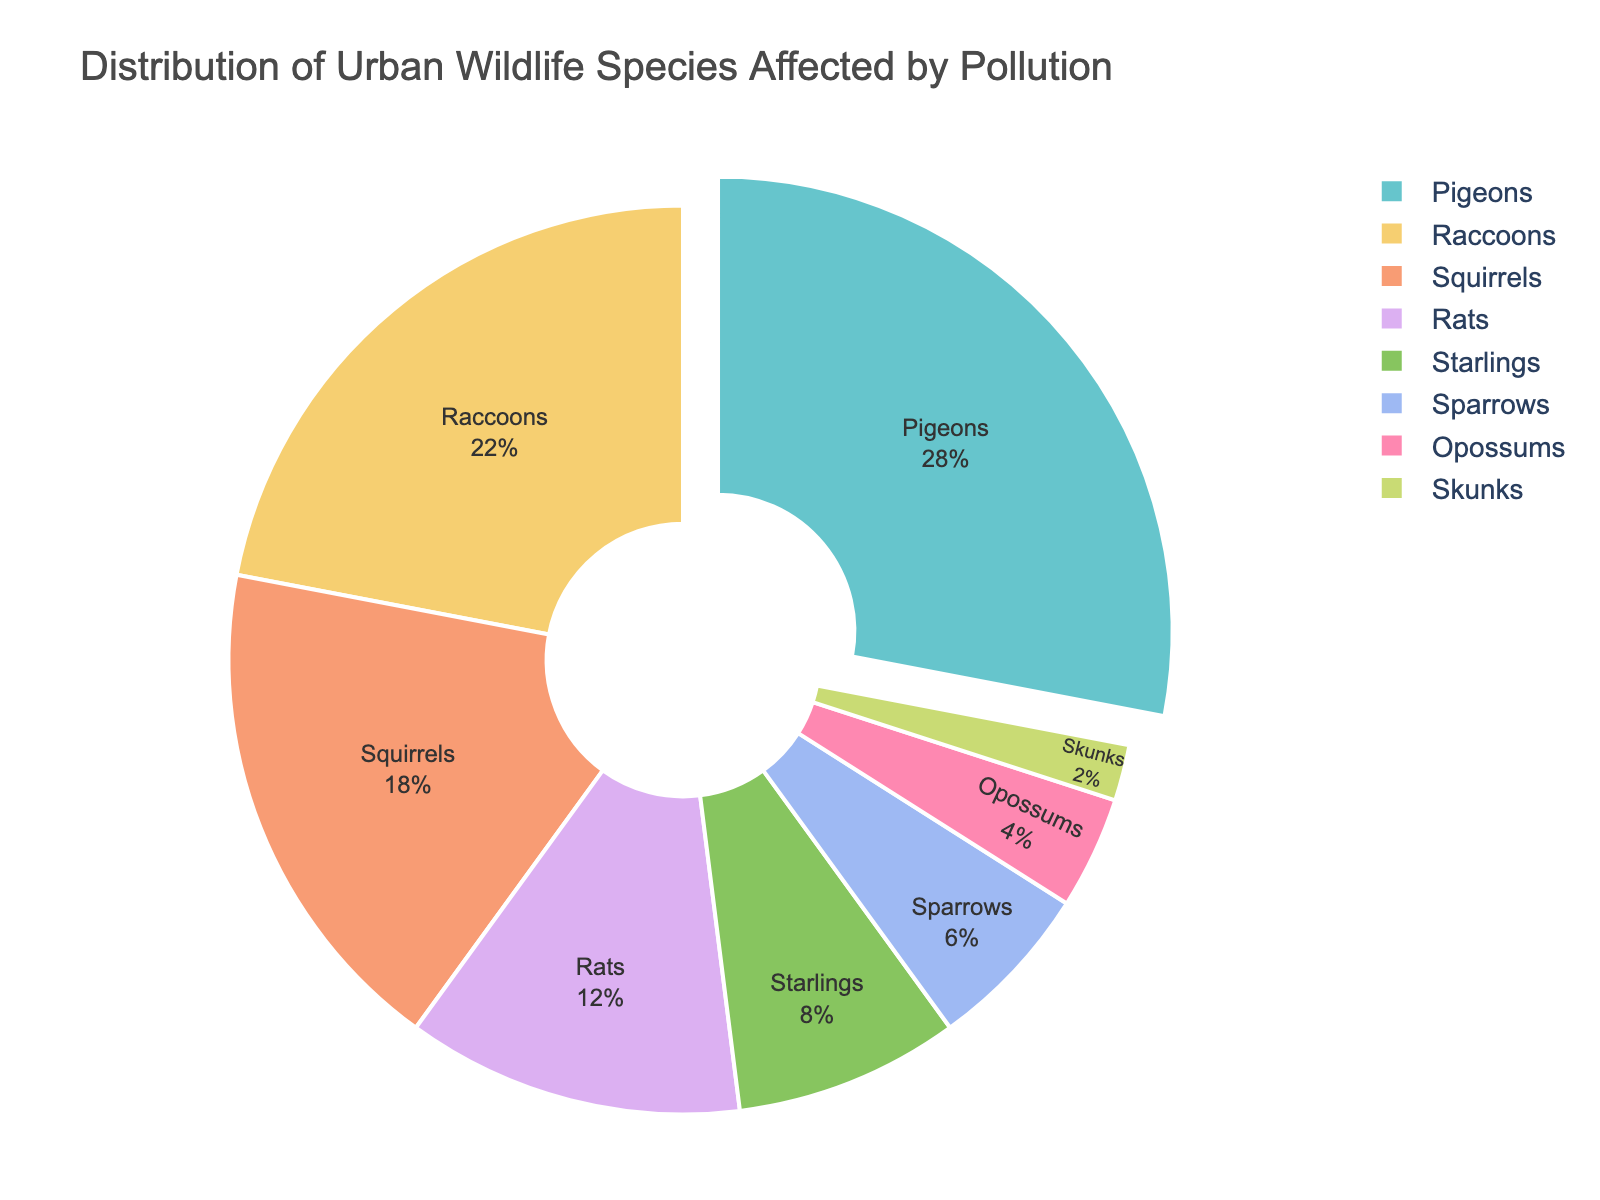what species of urban wildlife are most affected by pollution? According to the pie chart, the pie slice labeled 'Pigeons' is the largest segment, indicating that pigeons are the most affected by pollution, with 28% of the distribution.
Answer: Pigeons Which species account for more than 20% individually? By examining the chart, both the 'Pigeons' and 'Raccoons' categories have percentages above 20%. Specifically, Pigeons are 28% and Raccoons are 22%.
Answer: Pigeons and Raccoons How much more widespread are pigeons compared to squirrels? The chart shows pigeons at 28% and squirrels at 18%. Subtracting these values gives a difference of 10%.
Answer: 10% What's the combined percentage of Starlings and Sparrows? Adding the percentages of Starlings (8%) and Sparrows (6%) together gives a total of 14%.
Answer: 14% What's the least represented species in terms of pollution impact? The smallest segment on the chart is labeled 'Skunks', indicating a 2% impact.
Answer: Skunks Are rats or raccoons more affected by pollution, and by how much? The chart shows raccoons at 22% and rats at 12%. Subtracting these values gives a difference of 10%.
Answer: Raccoons by 10% What proportion of the chart is occupied by opossums and skunks combined? Opossums make up 4% and skunks make up 2%. Added together, they account for 6% of the chart.
Answer: 6% Which species groups are represented in the range of 5% to 10% inclusively? Within the range of 5% to 10%, we find 'Starlings' at 8% and 'Sparrows' at 6%.
Answer: Starlings and Sparrows How does the total percentage of species more impacted than rats compare to those less impacted? Summing percentages more impacted than rats: Pigeons (28%) + Raccoons (22%) + Squirrels (18%) totals 68%. Summing percentages less impacted: Starlings (8%) + Sparrows (6%) + Opossums (4%) + Skunks (2%) totals 20%. So, species more impacted sum to 68%.
Answer: 68% 